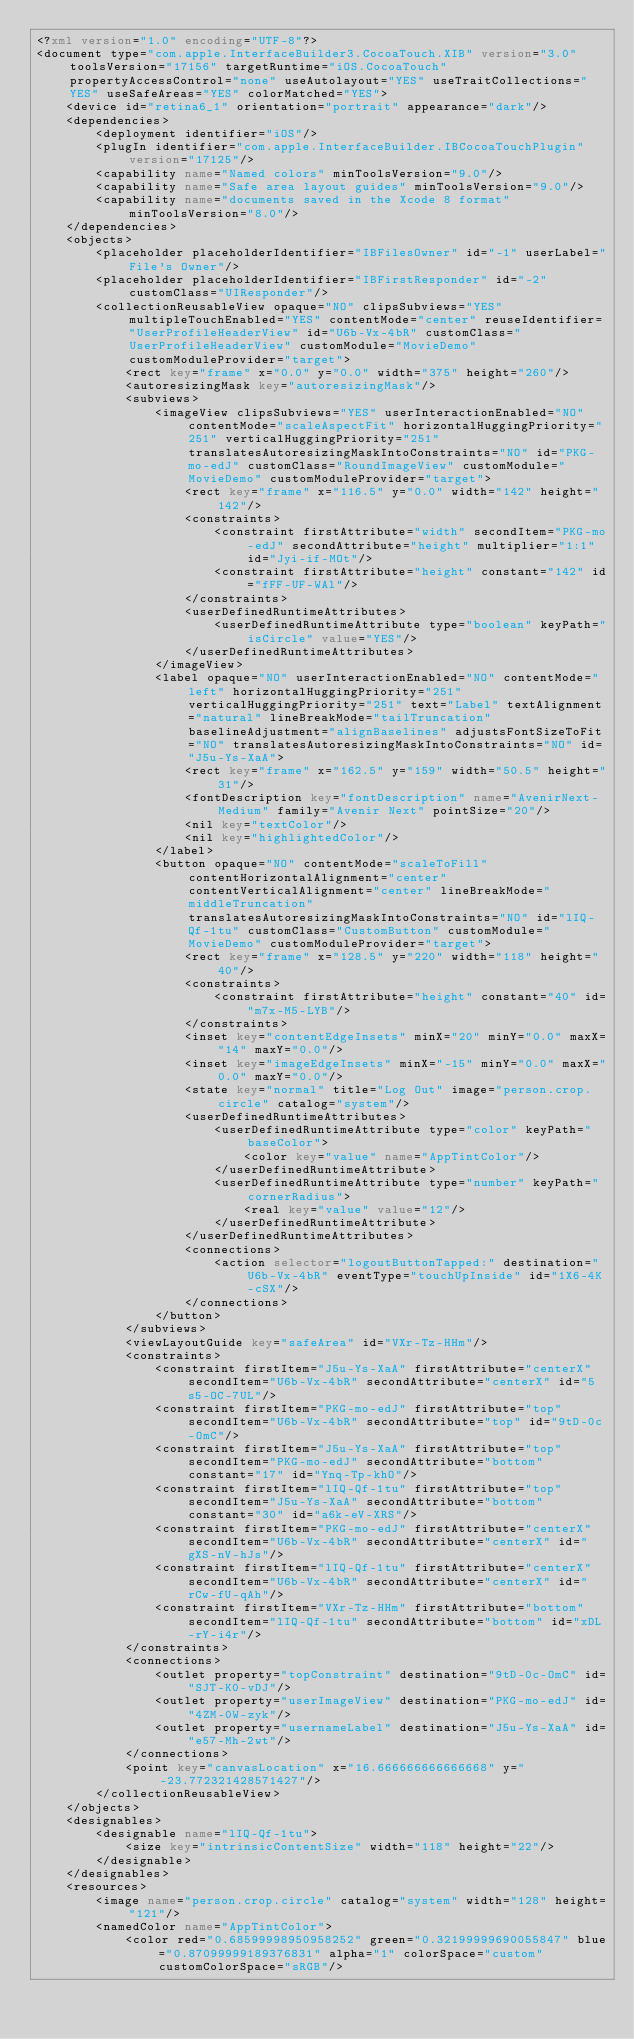<code> <loc_0><loc_0><loc_500><loc_500><_XML_><?xml version="1.0" encoding="UTF-8"?>
<document type="com.apple.InterfaceBuilder3.CocoaTouch.XIB" version="3.0" toolsVersion="17156" targetRuntime="iOS.CocoaTouch" propertyAccessControl="none" useAutolayout="YES" useTraitCollections="YES" useSafeAreas="YES" colorMatched="YES">
    <device id="retina6_1" orientation="portrait" appearance="dark"/>
    <dependencies>
        <deployment identifier="iOS"/>
        <plugIn identifier="com.apple.InterfaceBuilder.IBCocoaTouchPlugin" version="17125"/>
        <capability name="Named colors" minToolsVersion="9.0"/>
        <capability name="Safe area layout guides" minToolsVersion="9.0"/>
        <capability name="documents saved in the Xcode 8 format" minToolsVersion="8.0"/>
    </dependencies>
    <objects>
        <placeholder placeholderIdentifier="IBFilesOwner" id="-1" userLabel="File's Owner"/>
        <placeholder placeholderIdentifier="IBFirstResponder" id="-2" customClass="UIResponder"/>
        <collectionReusableView opaque="NO" clipsSubviews="YES" multipleTouchEnabled="YES" contentMode="center" reuseIdentifier="UserProfileHeaderView" id="U6b-Vx-4bR" customClass="UserProfileHeaderView" customModule="MovieDemo" customModuleProvider="target">
            <rect key="frame" x="0.0" y="0.0" width="375" height="260"/>
            <autoresizingMask key="autoresizingMask"/>
            <subviews>
                <imageView clipsSubviews="YES" userInteractionEnabled="NO" contentMode="scaleAspectFit" horizontalHuggingPriority="251" verticalHuggingPriority="251" translatesAutoresizingMaskIntoConstraints="NO" id="PKG-mo-edJ" customClass="RoundImageView" customModule="MovieDemo" customModuleProvider="target">
                    <rect key="frame" x="116.5" y="0.0" width="142" height="142"/>
                    <constraints>
                        <constraint firstAttribute="width" secondItem="PKG-mo-edJ" secondAttribute="height" multiplier="1:1" id="Jyi-if-MOt"/>
                        <constraint firstAttribute="height" constant="142" id="fFF-UF-WAl"/>
                    </constraints>
                    <userDefinedRuntimeAttributes>
                        <userDefinedRuntimeAttribute type="boolean" keyPath="isCircle" value="YES"/>
                    </userDefinedRuntimeAttributes>
                </imageView>
                <label opaque="NO" userInteractionEnabled="NO" contentMode="left" horizontalHuggingPriority="251" verticalHuggingPriority="251" text="Label" textAlignment="natural" lineBreakMode="tailTruncation" baselineAdjustment="alignBaselines" adjustsFontSizeToFit="NO" translatesAutoresizingMaskIntoConstraints="NO" id="J5u-Ys-XaA">
                    <rect key="frame" x="162.5" y="159" width="50.5" height="31"/>
                    <fontDescription key="fontDescription" name="AvenirNext-Medium" family="Avenir Next" pointSize="20"/>
                    <nil key="textColor"/>
                    <nil key="highlightedColor"/>
                </label>
                <button opaque="NO" contentMode="scaleToFill" contentHorizontalAlignment="center" contentVerticalAlignment="center" lineBreakMode="middleTruncation" translatesAutoresizingMaskIntoConstraints="NO" id="lIQ-Qf-1tu" customClass="CustomButton" customModule="MovieDemo" customModuleProvider="target">
                    <rect key="frame" x="128.5" y="220" width="118" height="40"/>
                    <constraints>
                        <constraint firstAttribute="height" constant="40" id="m7x-M5-LYB"/>
                    </constraints>
                    <inset key="contentEdgeInsets" minX="20" minY="0.0" maxX="14" maxY="0.0"/>
                    <inset key="imageEdgeInsets" minX="-15" minY="0.0" maxX="0.0" maxY="0.0"/>
                    <state key="normal" title="Log Out" image="person.crop.circle" catalog="system"/>
                    <userDefinedRuntimeAttributes>
                        <userDefinedRuntimeAttribute type="color" keyPath="baseColor">
                            <color key="value" name="AppTintColor"/>
                        </userDefinedRuntimeAttribute>
                        <userDefinedRuntimeAttribute type="number" keyPath="cornerRadius">
                            <real key="value" value="12"/>
                        </userDefinedRuntimeAttribute>
                    </userDefinedRuntimeAttributes>
                    <connections>
                        <action selector="logoutButtonTapped:" destination="U6b-Vx-4bR" eventType="touchUpInside" id="1X6-4K-cSX"/>
                    </connections>
                </button>
            </subviews>
            <viewLayoutGuide key="safeArea" id="VXr-Tz-HHm"/>
            <constraints>
                <constraint firstItem="J5u-Ys-XaA" firstAttribute="centerX" secondItem="U6b-Vx-4bR" secondAttribute="centerX" id="5s5-OC-7UL"/>
                <constraint firstItem="PKG-mo-edJ" firstAttribute="top" secondItem="U6b-Vx-4bR" secondAttribute="top" id="9tD-0c-OmC"/>
                <constraint firstItem="J5u-Ys-XaA" firstAttribute="top" secondItem="PKG-mo-edJ" secondAttribute="bottom" constant="17" id="Ynq-Tp-khO"/>
                <constraint firstItem="lIQ-Qf-1tu" firstAttribute="top" secondItem="J5u-Ys-XaA" secondAttribute="bottom" constant="30" id="a6k-eV-XRS"/>
                <constraint firstItem="PKG-mo-edJ" firstAttribute="centerX" secondItem="U6b-Vx-4bR" secondAttribute="centerX" id="gXS-nV-hJs"/>
                <constraint firstItem="lIQ-Qf-1tu" firstAttribute="centerX" secondItem="U6b-Vx-4bR" secondAttribute="centerX" id="rCw-fU-qAh"/>
                <constraint firstItem="VXr-Tz-HHm" firstAttribute="bottom" secondItem="lIQ-Qf-1tu" secondAttribute="bottom" id="xDL-rY-i4r"/>
            </constraints>
            <connections>
                <outlet property="topConstraint" destination="9tD-0c-OmC" id="SJT-K0-vDJ"/>
                <outlet property="userImageView" destination="PKG-mo-edJ" id="4ZM-0W-zyk"/>
                <outlet property="usernameLabel" destination="J5u-Ys-XaA" id="e57-Mh-2wt"/>
            </connections>
            <point key="canvasLocation" x="16.666666666666668" y="-23.772321428571427"/>
        </collectionReusableView>
    </objects>
    <designables>
        <designable name="lIQ-Qf-1tu">
            <size key="intrinsicContentSize" width="118" height="22"/>
        </designable>
    </designables>
    <resources>
        <image name="person.crop.circle" catalog="system" width="128" height="121"/>
        <namedColor name="AppTintColor">
            <color red="0.68599998950958252" green="0.32199999690055847" blue="0.87099999189376831" alpha="1" colorSpace="custom" customColorSpace="sRGB"/></code> 